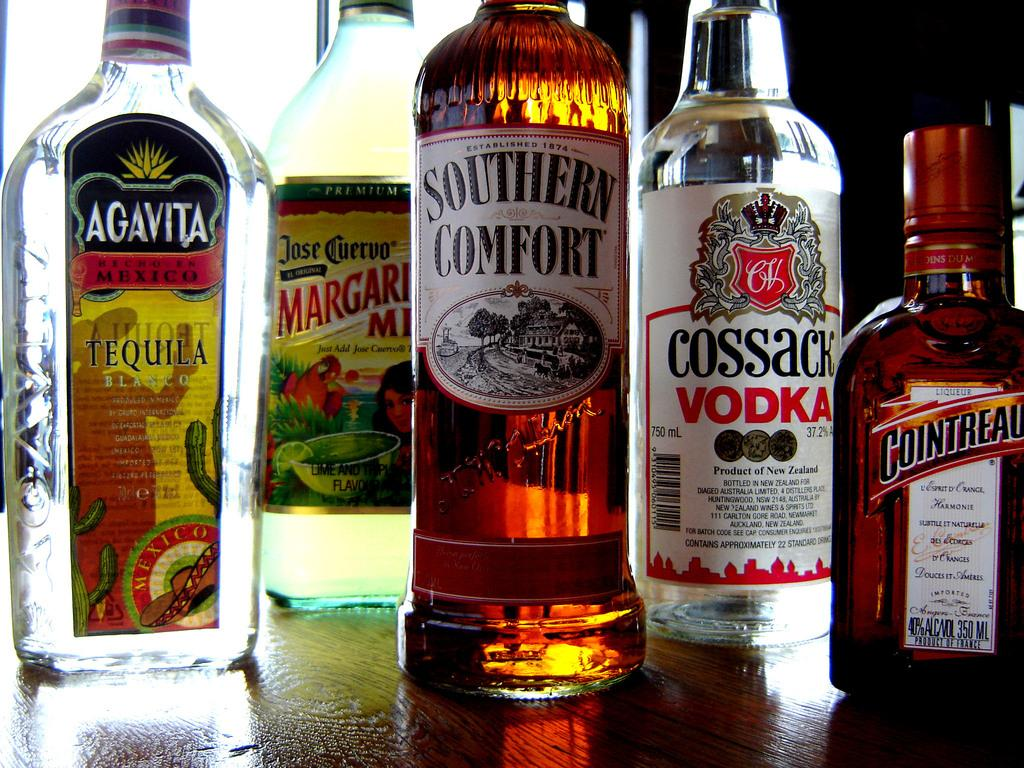<image>
Render a clear and concise summary of the photo. A bottle of Southern Comfort next to a bottle of Jose Cuervo Margarita mix. 